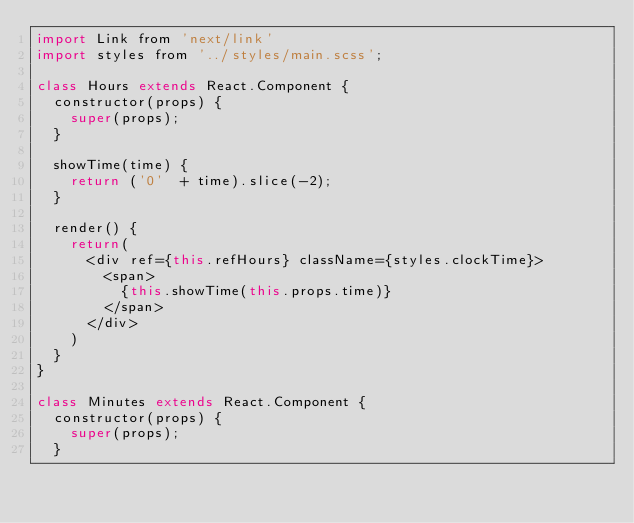<code> <loc_0><loc_0><loc_500><loc_500><_JavaScript_>import Link from 'next/link'
import styles from '../styles/main.scss';

class Hours extends React.Component {
  constructor(props) {
    super(props);
  }

  showTime(time) {
    return ('0'  + time).slice(-2);
  }

  render() {
    return(
      <div ref={this.refHours} className={styles.clockTime}>
        <span>
          {this.showTime(this.props.time)}
        </span>
      </div>
    )
  }
}

class Minutes extends React.Component {
  constructor(props) {
    super(props);
  }
</code> 